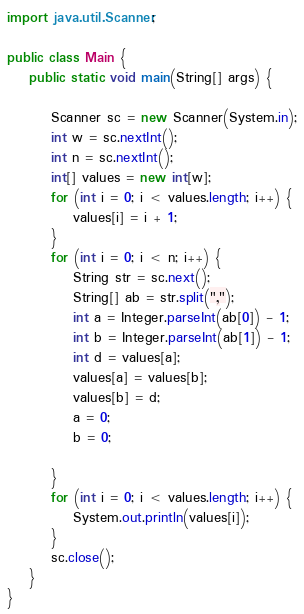Convert code to text. <code><loc_0><loc_0><loc_500><loc_500><_Java_>import java.util.Scanner;

public class Main {
	public static void main(String[] args) {

		Scanner sc = new Scanner(System.in);
		int w = sc.nextInt();
		int n = sc.nextInt();
		int[] values = new int[w];
		for (int i = 0; i < values.length; i++) {
			values[i] = i + 1;
		}
		for (int i = 0; i < n; i++) {
			String str = sc.next();
			String[] ab = str.split(",");
			int a = Integer.parseInt(ab[0]) - 1;
			int b = Integer.parseInt(ab[1]) - 1;
			int d = values[a];
			values[a] = values[b];
			values[b] = d;
			a = 0;
			b = 0;

		}
		for (int i = 0; i < values.length; i++) {
			System.out.println(values[i]);
		}
		sc.close();
	}
}</code> 